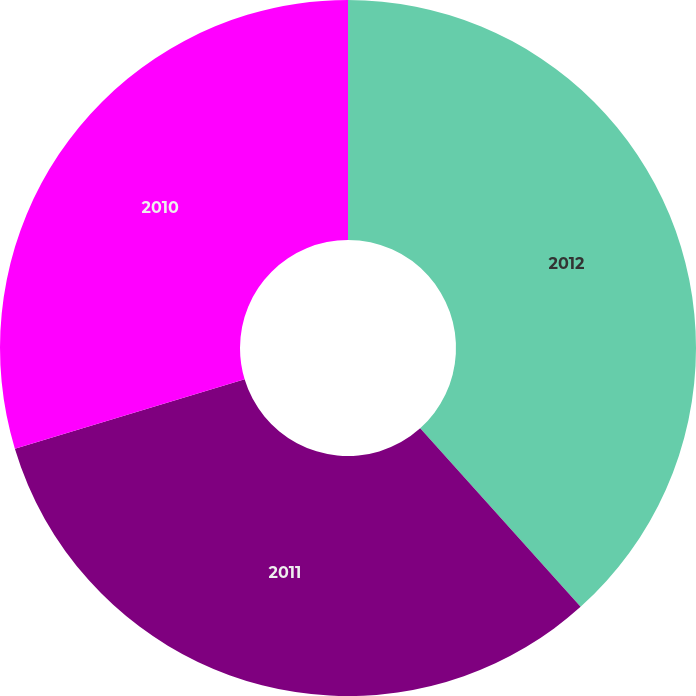<chart> <loc_0><loc_0><loc_500><loc_500><pie_chart><fcel>2012<fcel>2011<fcel>2010<nl><fcel>38.35%<fcel>31.98%<fcel>29.67%<nl></chart> 